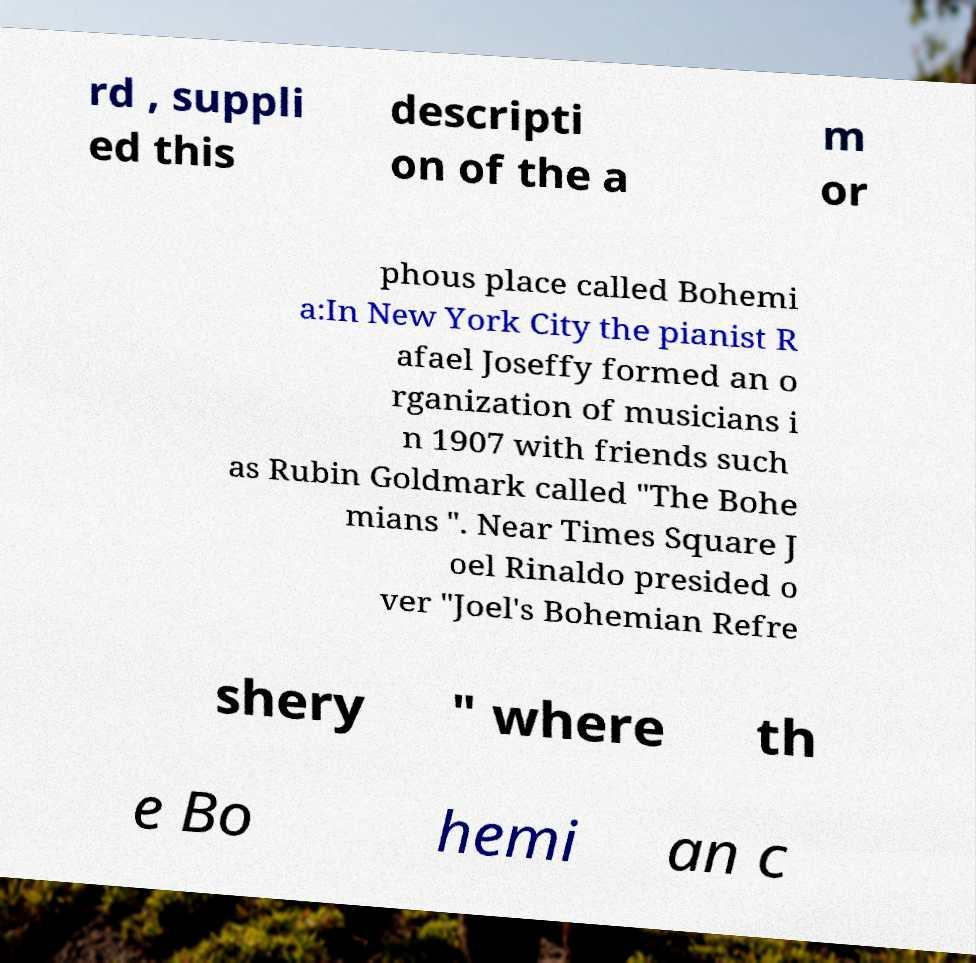What messages or text are displayed in this image? I need them in a readable, typed format. rd , suppli ed this descripti on of the a m or phous place called Bohemi a:In New York City the pianist R afael Joseffy formed an o rganization of musicians i n 1907 with friends such as Rubin Goldmark called "The Bohe mians ". Near Times Square J oel Rinaldo presided o ver "Joel's Bohemian Refre shery " where th e Bo hemi an c 